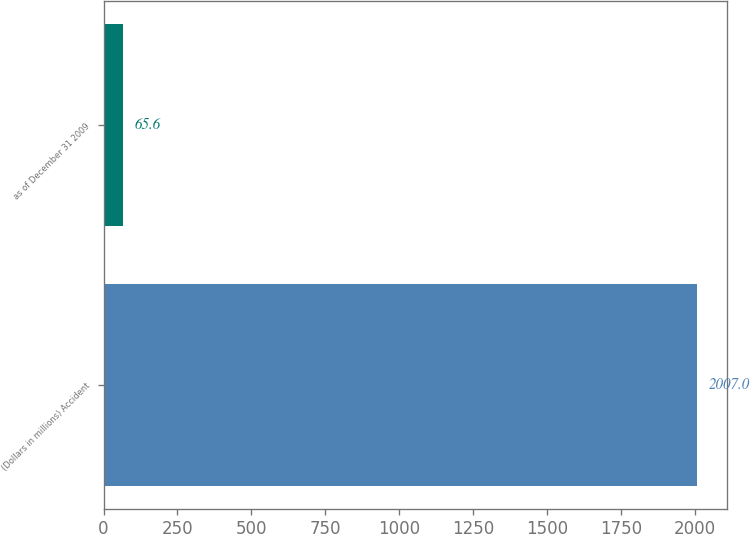Convert chart to OTSL. <chart><loc_0><loc_0><loc_500><loc_500><bar_chart><fcel>(Dollars in millions) Accident<fcel>as of December 31 2009<nl><fcel>2007<fcel>65.6<nl></chart> 